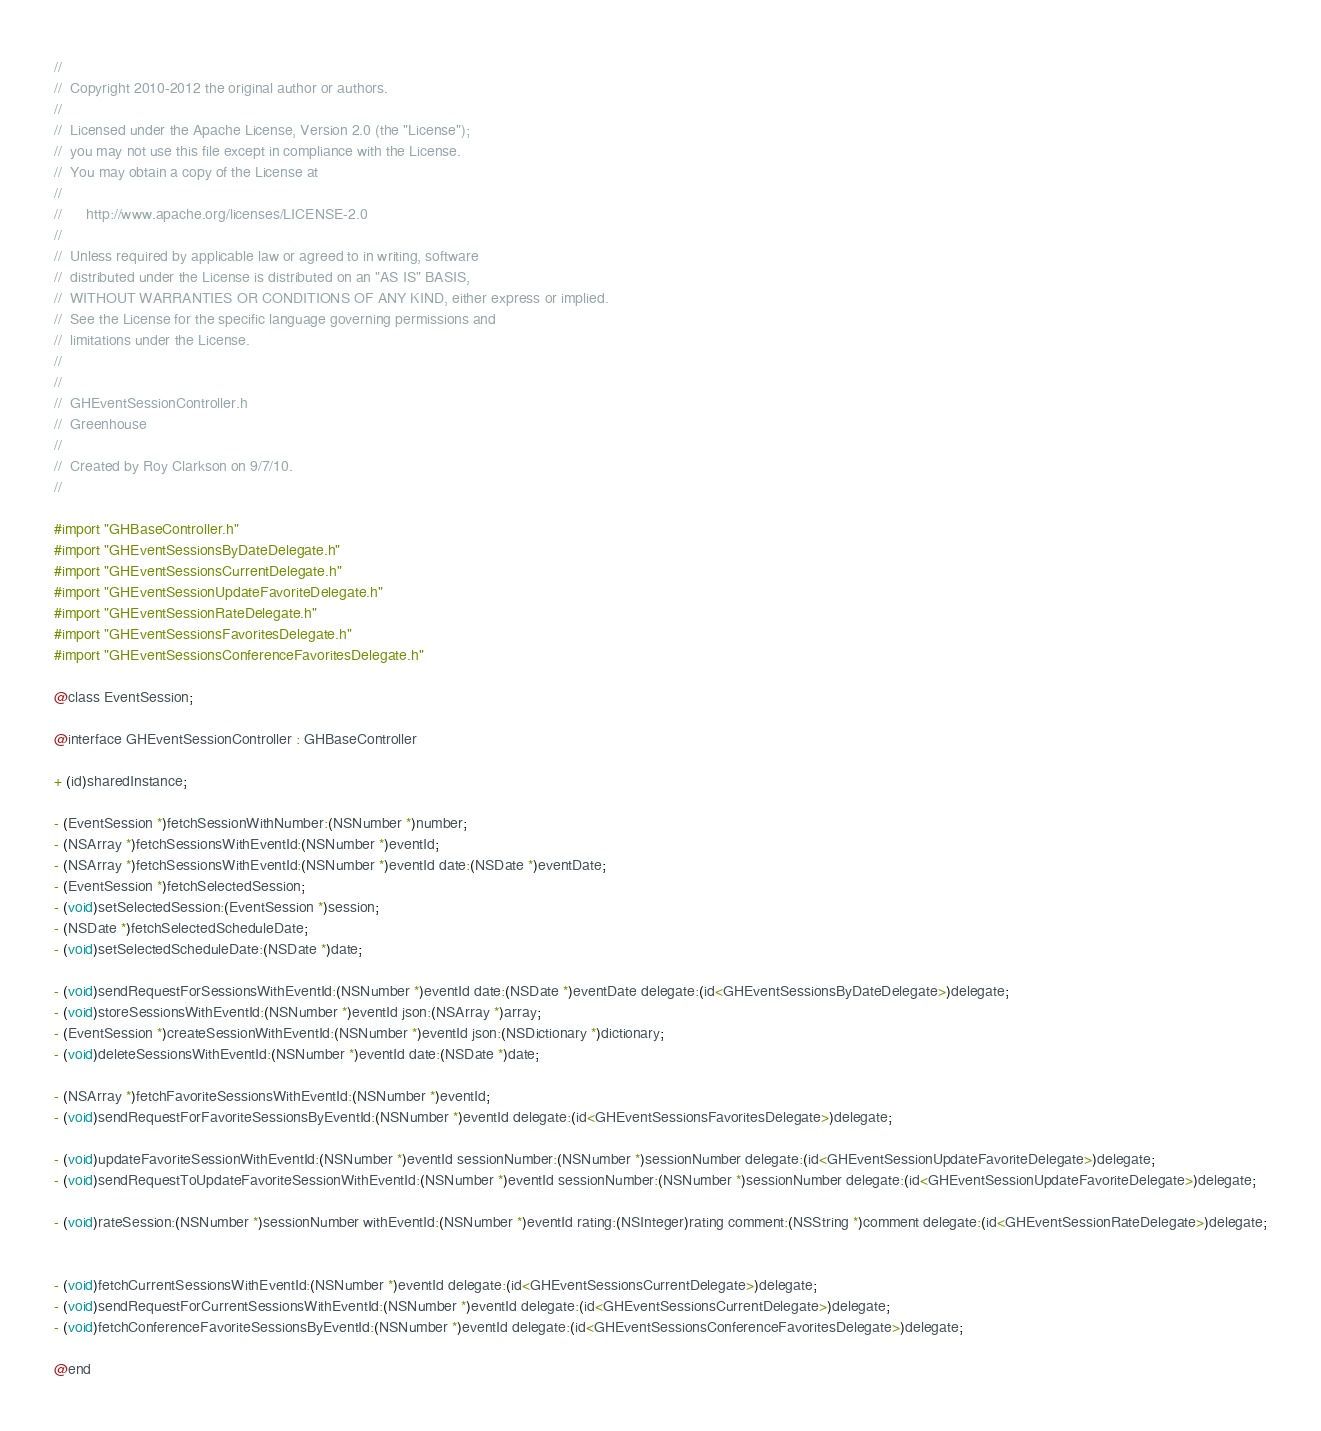<code> <loc_0><loc_0><loc_500><loc_500><_C_>//
//  Copyright 2010-2012 the original author or authors.
//
//  Licensed under the Apache License, Version 2.0 (the "License");
//  you may not use this file except in compliance with the License.
//  You may obtain a copy of the License at
//
//      http://www.apache.org/licenses/LICENSE-2.0
//
//  Unless required by applicable law or agreed to in writing, software
//  distributed under the License is distributed on an "AS IS" BASIS,
//  WITHOUT WARRANTIES OR CONDITIONS OF ANY KIND, either express or implied.
//  See the License for the specific language governing permissions and
//  limitations under the License.
//
//
//  GHEventSessionController.h
//  Greenhouse
//
//  Created by Roy Clarkson on 9/7/10.
//

#import "GHBaseController.h"
#import "GHEventSessionsByDateDelegate.h"
#import "GHEventSessionsCurrentDelegate.h"
#import "GHEventSessionUpdateFavoriteDelegate.h"
#import "GHEventSessionRateDelegate.h"
#import "GHEventSessionsFavoritesDelegate.h"
#import "GHEventSessionsConferenceFavoritesDelegate.h"

@class EventSession;

@interface GHEventSessionController : GHBaseController

+ (id)sharedInstance;

- (EventSession *)fetchSessionWithNumber:(NSNumber *)number;
- (NSArray *)fetchSessionsWithEventId:(NSNumber *)eventId;
- (NSArray *)fetchSessionsWithEventId:(NSNumber *)eventId date:(NSDate *)eventDate;
- (EventSession *)fetchSelectedSession;
- (void)setSelectedSession:(EventSession *)session;
- (NSDate *)fetchSelectedScheduleDate;
- (void)setSelectedScheduleDate:(NSDate *)date;

- (void)sendRequestForSessionsWithEventId:(NSNumber *)eventId date:(NSDate *)eventDate delegate:(id<GHEventSessionsByDateDelegate>)delegate;
- (void)storeSessionsWithEventId:(NSNumber *)eventId json:(NSArray *)array;
- (EventSession *)createSessionWithEventId:(NSNumber *)eventId json:(NSDictionary *)dictionary;
- (void)deleteSessionsWithEventId:(NSNumber *)eventId date:(NSDate *)date;

- (NSArray *)fetchFavoriteSessionsWithEventId:(NSNumber *)eventId;
- (void)sendRequestForFavoriteSessionsByEventId:(NSNumber *)eventId delegate:(id<GHEventSessionsFavoritesDelegate>)delegate;

- (void)updateFavoriteSessionWithEventId:(NSNumber *)eventId sessionNumber:(NSNumber *)sessionNumber delegate:(id<GHEventSessionUpdateFavoriteDelegate>)delegate;
- (void)sendRequestToUpdateFavoriteSessionWithEventId:(NSNumber *)eventId sessionNumber:(NSNumber *)sessionNumber delegate:(id<GHEventSessionUpdateFavoriteDelegate>)delegate;

- (void)rateSession:(NSNumber *)sessionNumber withEventId:(NSNumber *)eventId rating:(NSInteger)rating comment:(NSString *)comment delegate:(id<GHEventSessionRateDelegate>)delegate;


- (void)fetchCurrentSessionsWithEventId:(NSNumber *)eventId delegate:(id<GHEventSessionsCurrentDelegate>)delegate;
- (void)sendRequestForCurrentSessionsWithEventId:(NSNumber *)eventId delegate:(id<GHEventSessionsCurrentDelegate>)delegate;
- (void)fetchConferenceFavoriteSessionsByEventId:(NSNumber *)eventId delegate:(id<GHEventSessionsConferenceFavoritesDelegate>)delegate;

@end

</code> 